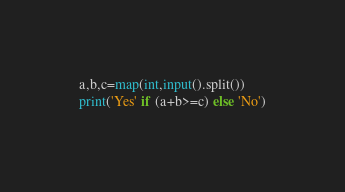<code> <loc_0><loc_0><loc_500><loc_500><_Python_>a,b,c=map(int,input().split())
print('Yes' if (a+b>=c) else 'No')</code> 